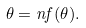Convert formula to latex. <formula><loc_0><loc_0><loc_500><loc_500>\theta = n f ( \theta ) .</formula> 